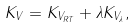Convert formula to latex. <formula><loc_0><loc_0><loc_500><loc_500>K _ { V } = K _ { V _ { R T } } + \lambda K _ { V _ { \lambda } } ,</formula> 